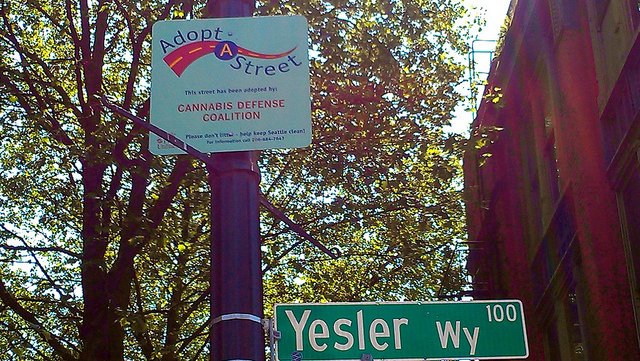Extract all visible text content from this image. CANNABIS DEFENCE COALITION yesler WY 100 street Adopt 